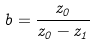Convert formula to latex. <formula><loc_0><loc_0><loc_500><loc_500>b = \frac { z _ { 0 } } { z _ { 0 } - z _ { 1 } }</formula> 